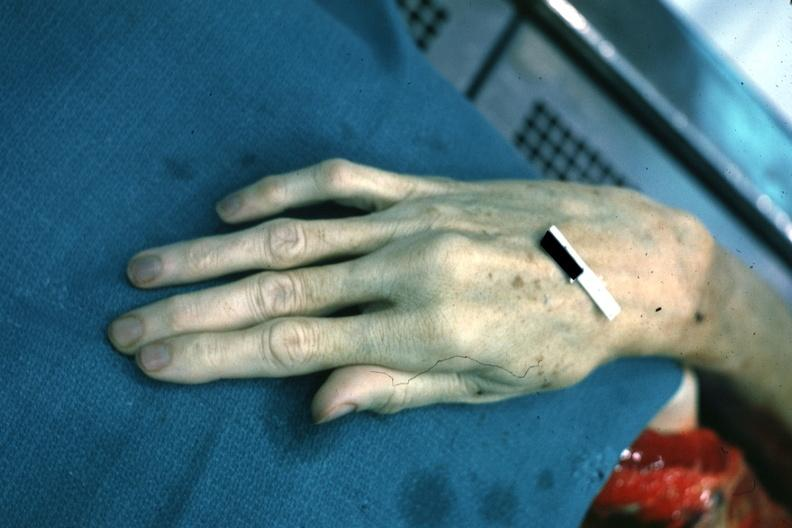re extremities present?
Answer the question using a single word or phrase. Yes 